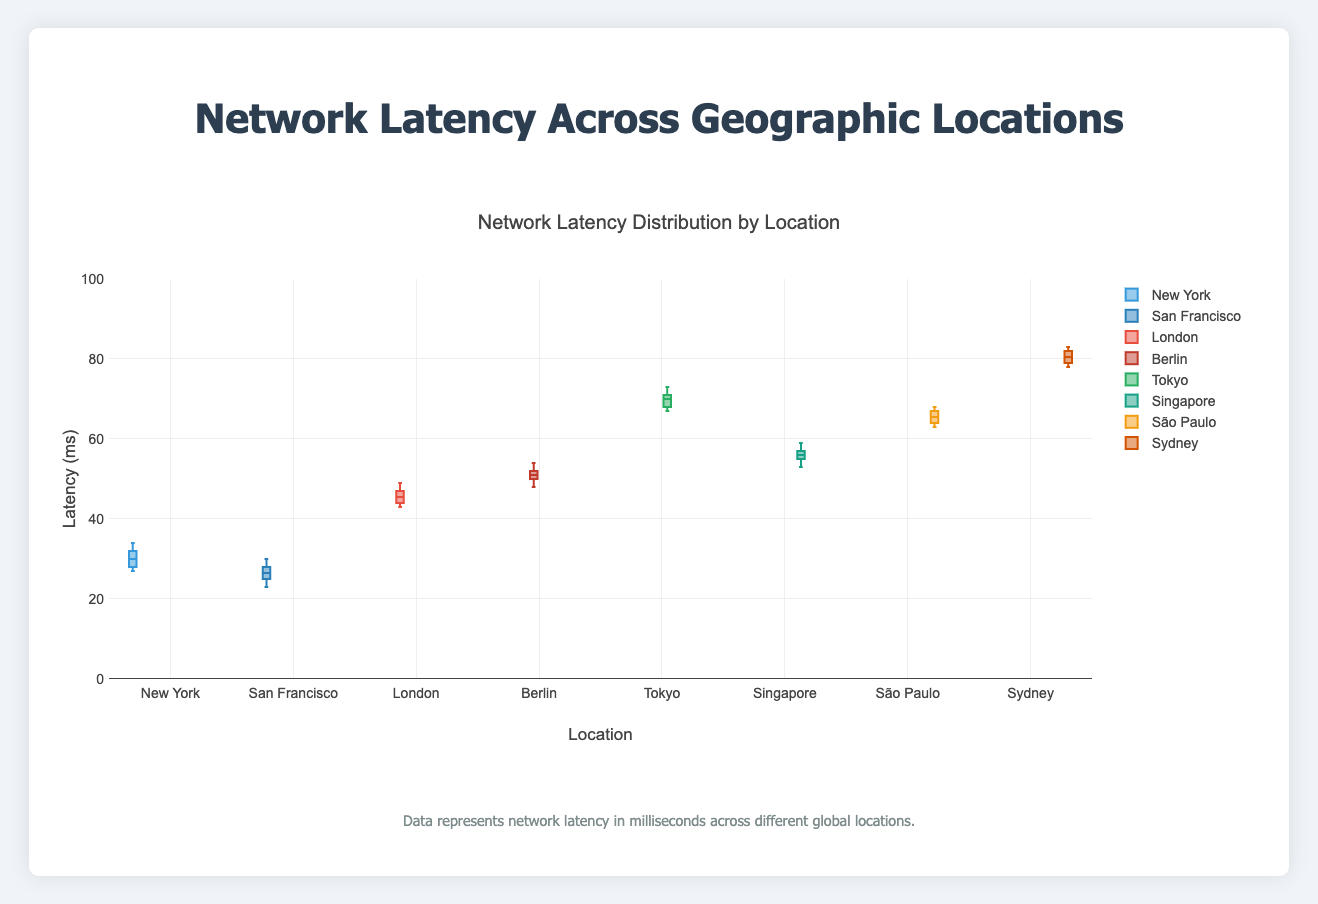What's the title of the figure? The title of the figure is displayed prominently at the top and reads "Network Latency Distribution by Location".
Answer: Network Latency Distribution by Location What is the range of the y-axis? The y-axis represents the latency in milliseconds and the range is labeled from 0 to 100.
Answer: 0 to 100 How many geographic locations are analyzed in this figure? There are eight geographic locations, each represented by one box plot.
Answer: Eight Which location has the highest median latency? By observing the median line within each box, Sydney has the highest median latency.
Answer: Sydney What is the median latency value for New York? The median value is indicated by the line inside the box for New York, which is at approximately 30 ms.
Answer: 30 ms Which location has the smallest interquartile range (IQR) in latency? The interquartile range is the height of the box; San Francisco has the smallest box, implying the smallest IQR.
Answer: San Francisco What is the difference between the maximum latencies of Tokyo and São Paulo? The maximum latency is the top whisker of the box plot, with Tokyo at around 73 ms and São Paulo at 68 ms. The difference is 73 - 68.
Answer: 5 ms Compare the median latencies of London and Berlin. London has a median latency around 45 ms, while Berlin's median is around 51 ms, making Berlin's median higher.
Answer: Berlin has a higher median latency Which location has the highest range in latency values? The range is the difference between the top whisker and bottom whisker; Sydney's range appears the largest, going from approximately 78 ms to 83 ms.
Answer: Sydney What can you infer about latency in different geographic regions from this figure? The latencies vary across different regions with some clustering, such as lower latencies in North America (New York and San Francisco), and higher latencies in Oceania (Sydney) and Asia (Tokyo).
Answer: Latencies vary significantly by region, with certain regions showing distinct clustering 